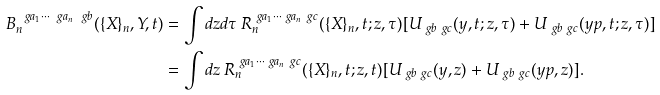<formula> <loc_0><loc_0><loc_500><loc_500>B _ { n } ^ { \ g a _ { 1 } \cdots \ g a _ { n } \ g b } ( \{ X \} _ { n } , Y , t ) & = \int d z d \tau \, R _ { n } ^ { \ g a _ { 1 } \cdots \ g a _ { n } \ g c } ( \{ X \} _ { n } , t ; z , \tau ) [ U _ { \ g b \ g c } ( y , t ; z , \tau ) + U _ { \ g b \ g c } ( y p , t ; z , \tau ) ] \\ & = \int d z \, R _ { n } ^ { \ g a _ { 1 } \cdots \ g a _ { n } \ g c } ( \{ X \} _ { n } , t ; z , t ) [ U _ { \ g b \ g c } ( y , z ) + U _ { \ g b \ g c } ( y p , z ) ] .</formula> 